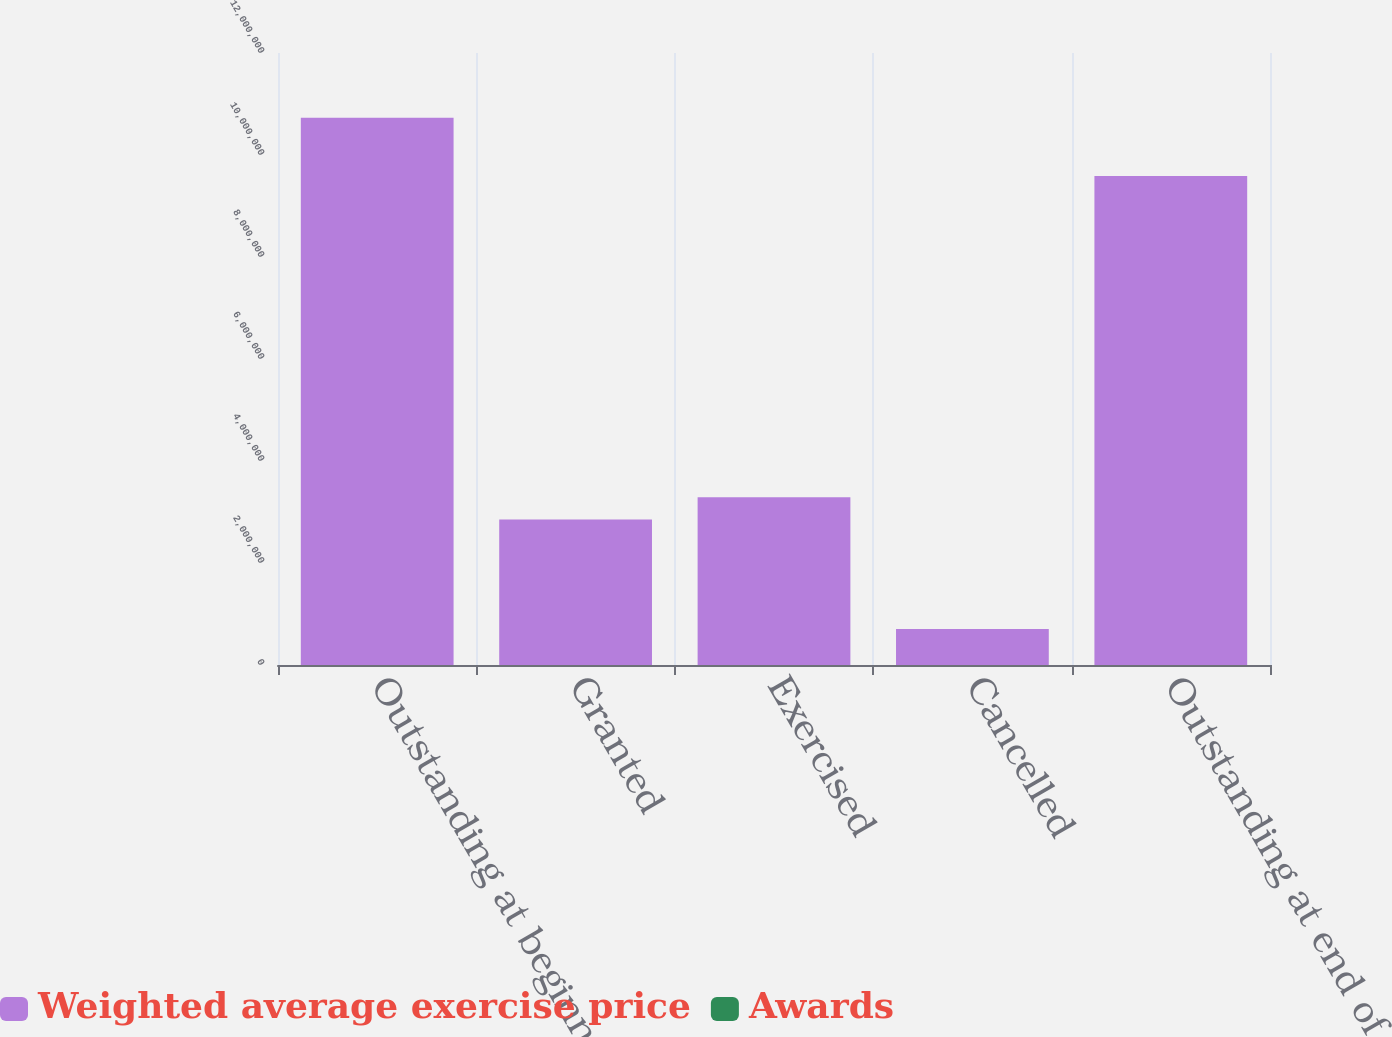Convert chart. <chart><loc_0><loc_0><loc_500><loc_500><stacked_bar_chart><ecel><fcel>Outstanding at beginning of<fcel>Granted<fcel>Exercised<fcel>Cancelled<fcel>Outstanding at end of year<nl><fcel>Weighted average exercise price<fcel>1.07321e+07<fcel>2.85094e+06<fcel>3.28899e+06<fcel>705629<fcel>9.58846e+06<nl><fcel>Awards<fcel>16.38<fcel>45.63<fcel>12.81<fcel>22.68<fcel>25.84<nl></chart> 